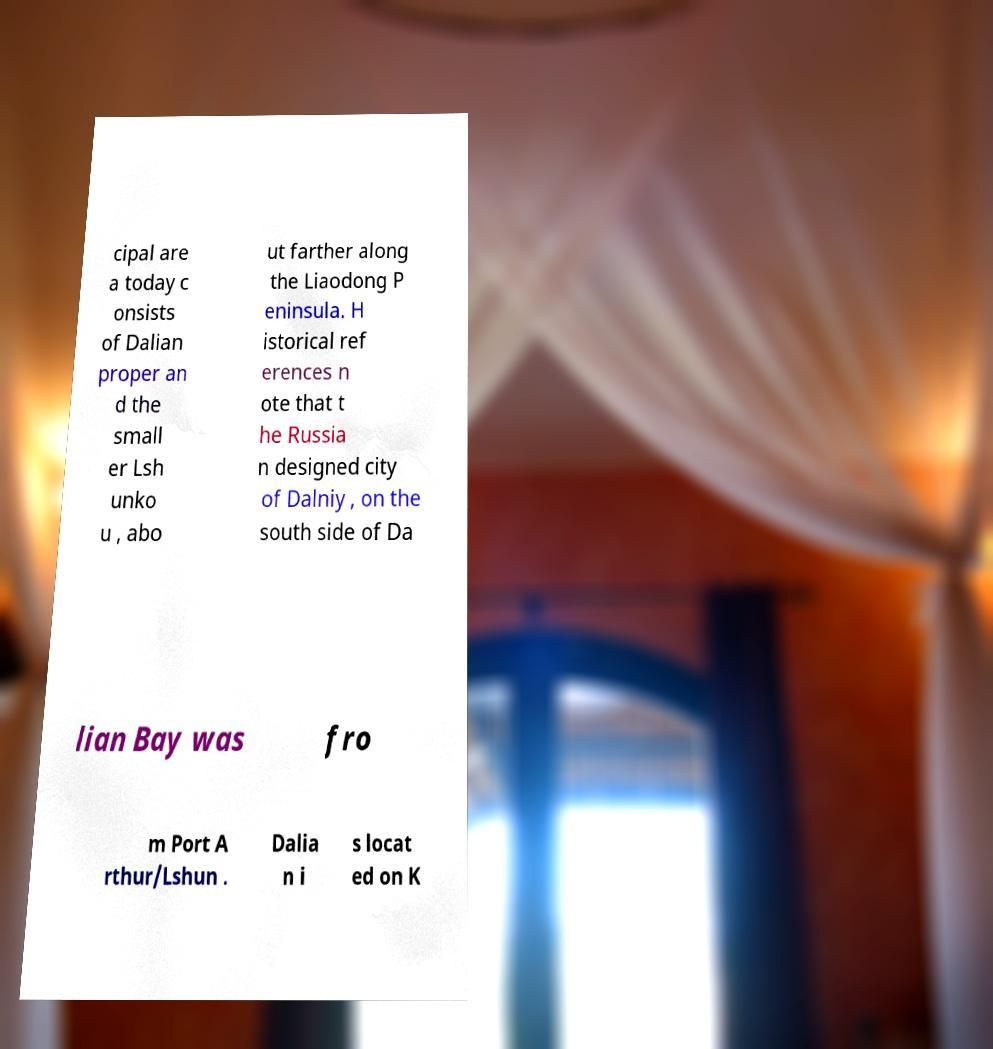Please read and relay the text visible in this image. What does it say? cipal are a today c onsists of Dalian proper an d the small er Lsh unko u , abo ut farther along the Liaodong P eninsula. H istorical ref erences n ote that t he Russia n designed city of Dalniy , on the south side of Da lian Bay was fro m Port A rthur/Lshun . Dalia n i s locat ed on K 